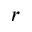Convert formula to latex. <formula><loc_0><loc_0><loc_500><loc_500>r</formula> 